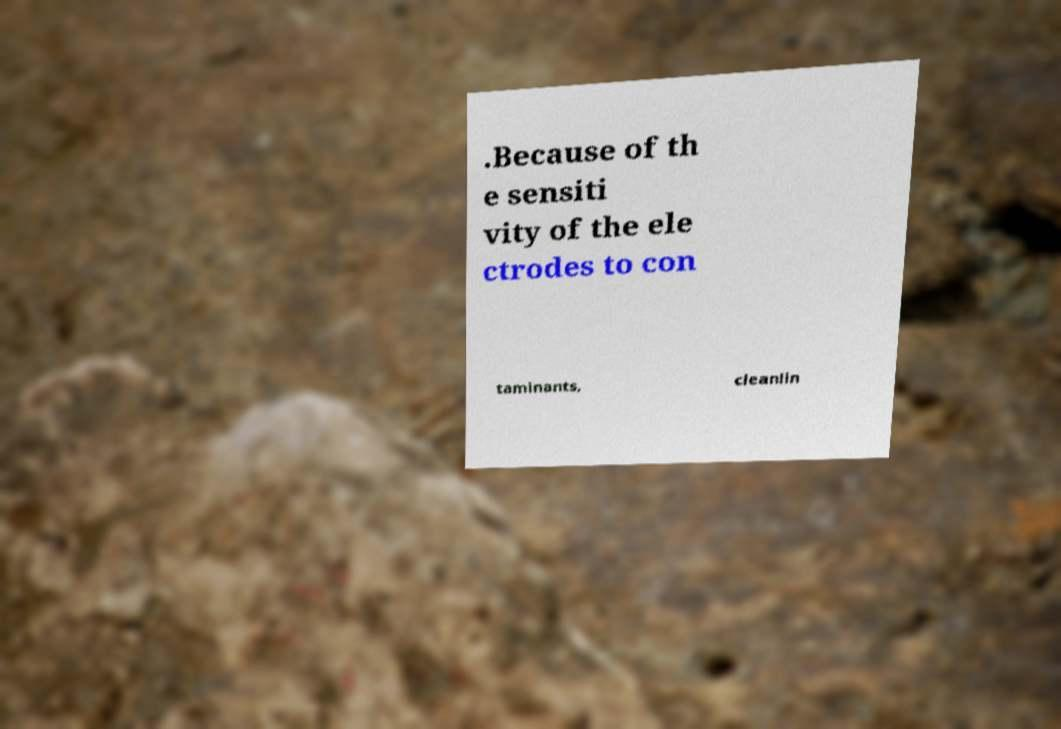I need the written content from this picture converted into text. Can you do that? .Because of th e sensiti vity of the ele ctrodes to con taminants, cleanlin 